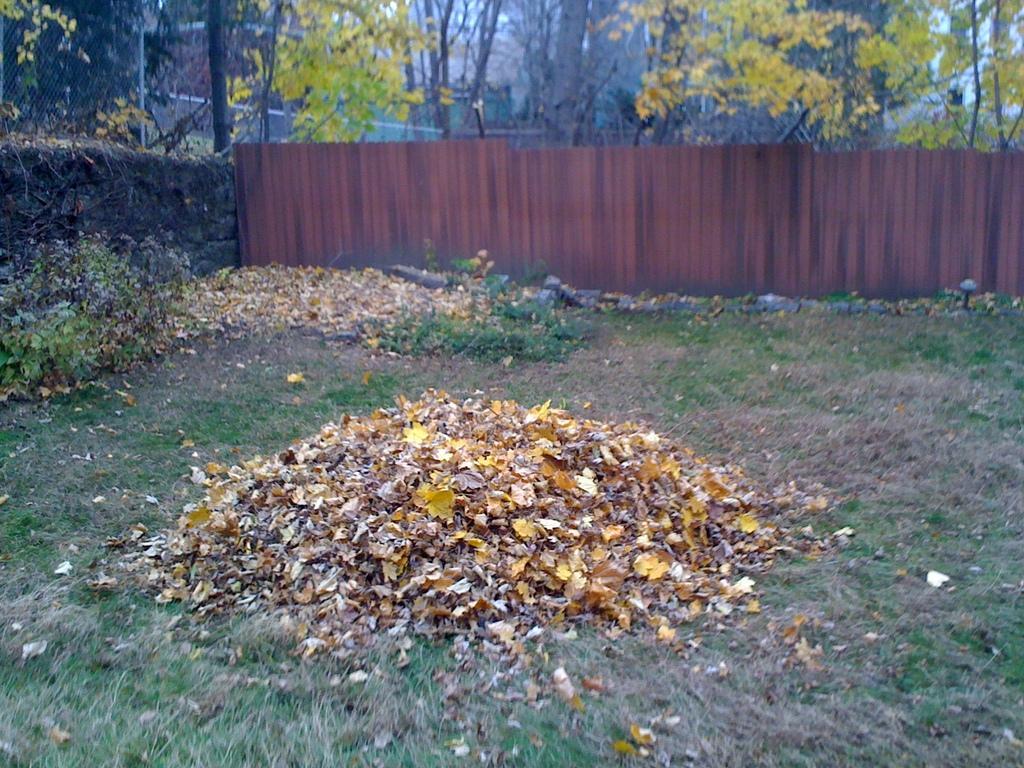Please provide a concise description of this image. Here I can see few dry leaves on the ground and also I can see the grass and plants. In the background there is a fencing and wall. At the back of there are some trees. 